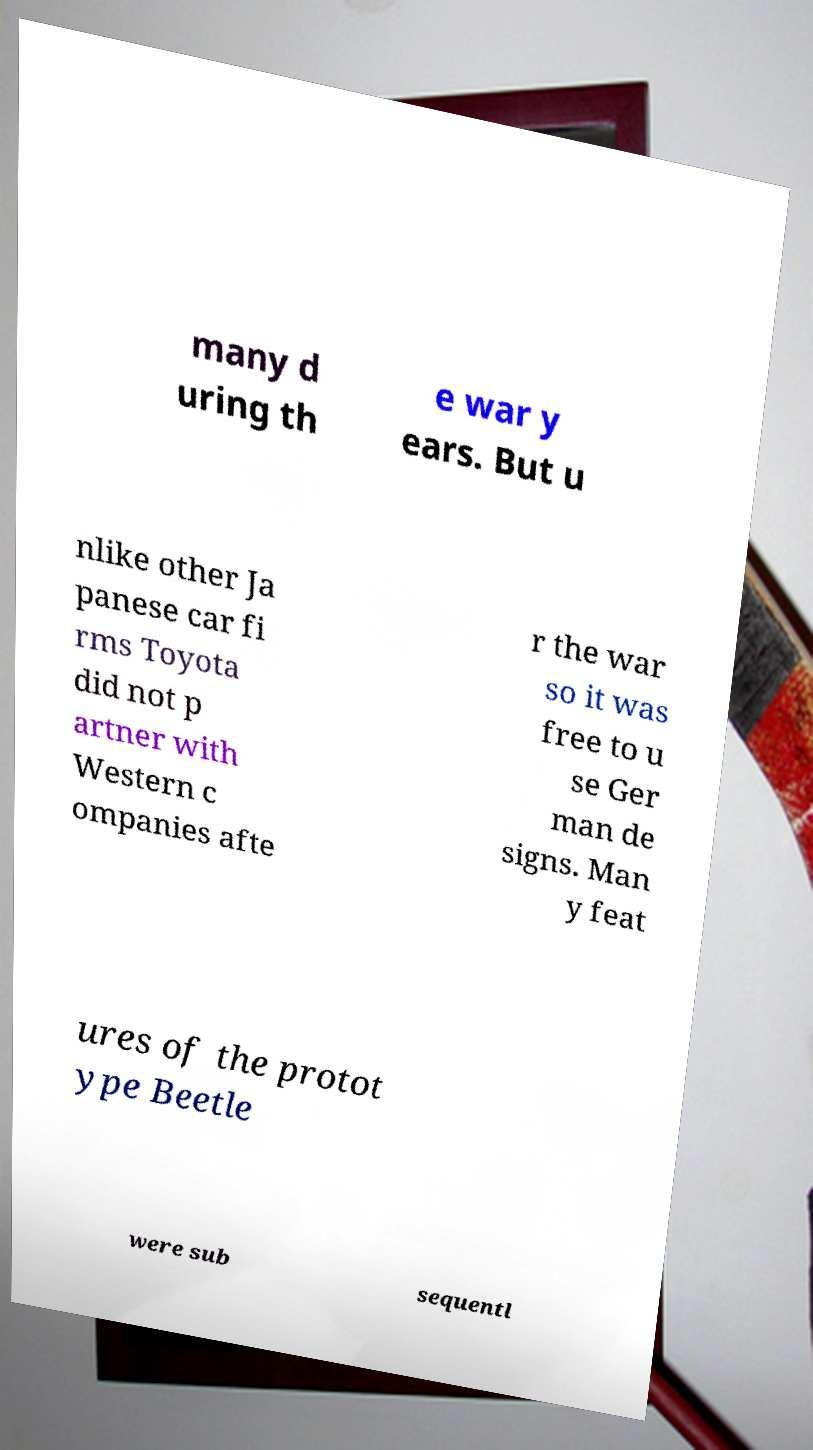Please identify and transcribe the text found in this image. many d uring th e war y ears. But u nlike other Ja panese car fi rms Toyota did not p artner with Western c ompanies afte r the war so it was free to u se Ger man de signs. Man y feat ures of the protot ype Beetle were sub sequentl 